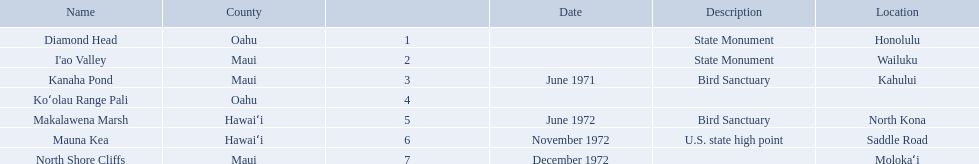What are all the landmark names? Diamond Head, I'ao Valley, Kanaha Pond, Koʻolau Range Pali, Makalawena Marsh, Mauna Kea, North Shore Cliffs. Which county is each landlord in? Oahu, Maui, Maui, Oahu, Hawaiʻi, Hawaiʻi, Maui. Along with mauna kea, which landmark is in hawai'i county? Makalawena Marsh. Which national natural landmarks in hawaii are in oahu county? Diamond Head, Koʻolau Range Pali. Of these landmarks, which one is listed without a location? Koʻolau Range Pali. What are the national natural landmarks in hawaii? Diamond Head, I'ao Valley, Kanaha Pond, Koʻolau Range Pali, Makalawena Marsh, Mauna Kea, North Shore Cliffs. Which of theses are in hawa'i county? Makalawena Marsh, Mauna Kea. Of these which has a bird sanctuary? Makalawena Marsh. 